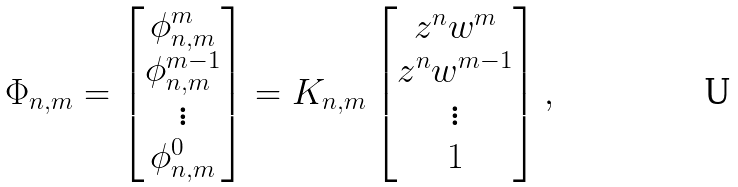<formula> <loc_0><loc_0><loc_500><loc_500>\Phi _ { n , m } = \left [ \begin{matrix} \phi _ { n , m } ^ { m } \\ \phi _ { n , m } ^ { m - 1 } \\ \vdots \\ \phi _ { n , m } ^ { 0 } \end{matrix} \right ] = K _ { n , m } \left [ \begin{matrix} z ^ { n } w ^ { m } \\ z ^ { n } w ^ { m - 1 } \\ \vdots \\ 1 \end{matrix} \right ] ,</formula> 